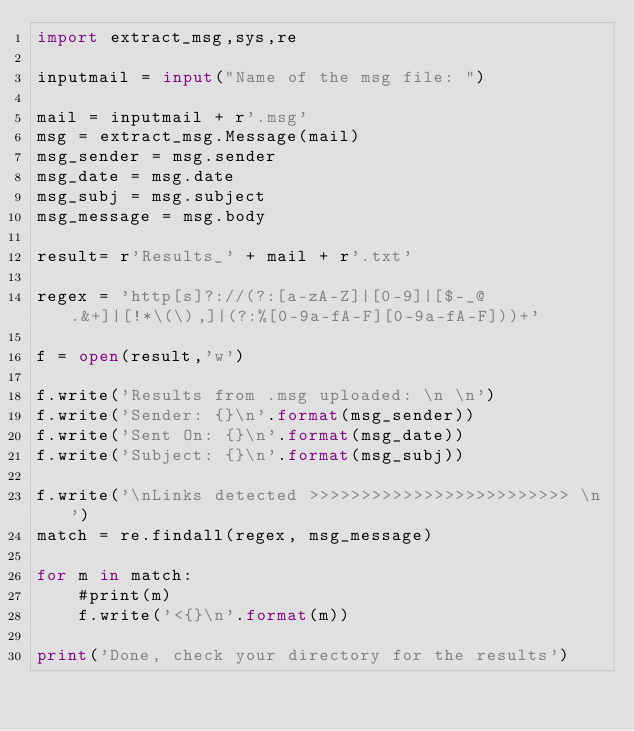Convert code to text. <code><loc_0><loc_0><loc_500><loc_500><_Python_>import extract_msg,sys,re

inputmail = input("Name of the msg file: ")

mail = inputmail + r'.msg'
msg = extract_msg.Message(mail)
msg_sender = msg.sender
msg_date = msg.date
msg_subj = msg.subject
msg_message = msg.body

result= r'Results_' + mail + r'.txt'

regex = 'http[s]?://(?:[a-zA-Z]|[0-9]|[$-_@.&+]|[!*\(\),]|(?:%[0-9a-fA-F][0-9a-fA-F]))+'

f = open(result,'w')

f.write('Results from .msg uploaded: \n \n')
f.write('Sender: {}\n'.format(msg_sender))
f.write('Sent On: {}\n'.format(msg_date))
f.write('Subject: {}\n'.format(msg_subj))

f.write('\nLinks detected >>>>>>>>>>>>>>>>>>>>>>>>> \n')
match = re.findall(regex, msg_message)

for m in match:
    #print(m)
    f.write('<{}\n'.format(m))

print('Done, check your directory for the results')
</code> 